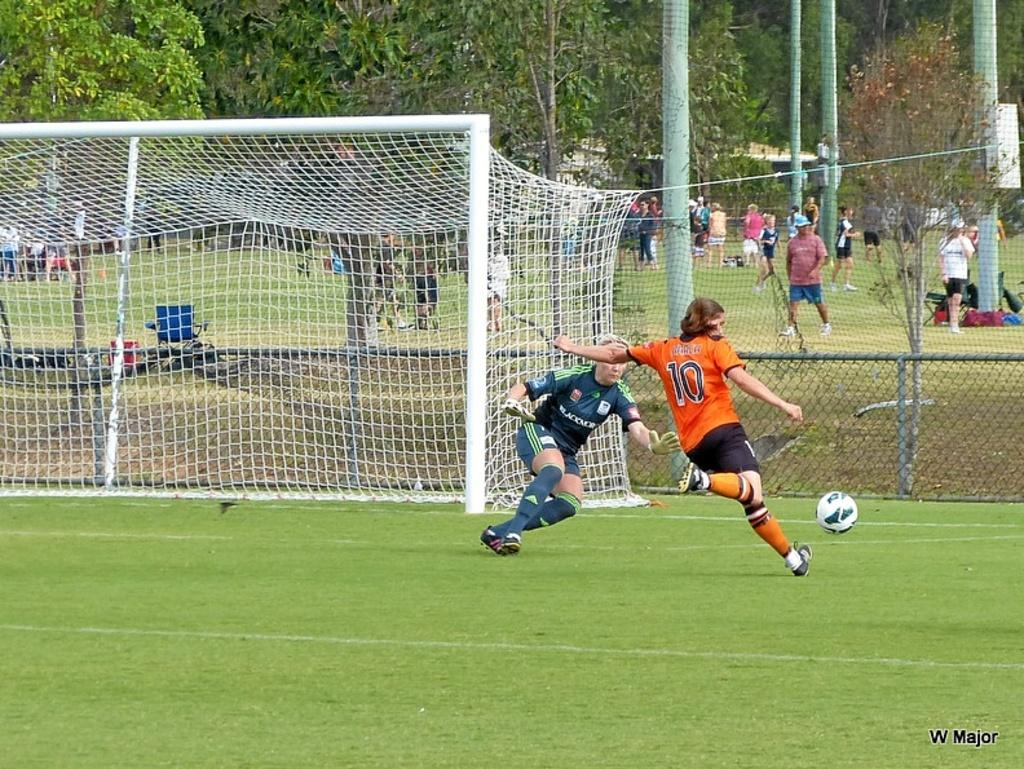<image>
Write a terse but informative summary of the picture. Player number 10 is getting ready to strike the ball into the net. 